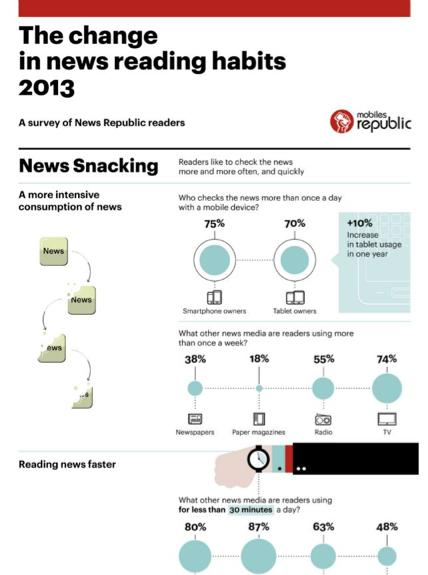Point out several critical features in this image. According to a survey of New Republic Readers in 2013, 70% of people reported that they check the news for more than once a day on their tablets. According to a survey of New Republic Readers in 2013, 75% of people reported checking the news on their smartphones for more than once a day. 